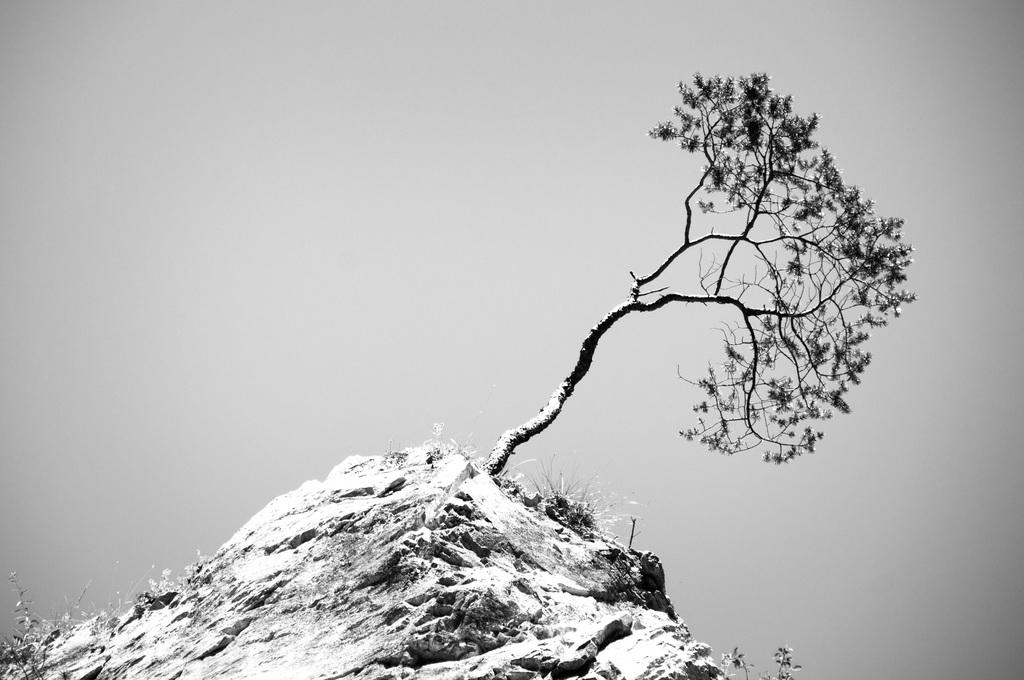What natural feature is located on the mountain in the image? There is a tree on a mountain in the image. What type of vegetation can be seen at the bottom left corner of the image? There is grass at the bottom left corner of the image. What can be seen in the background of the image? The sky is visible in the background of the image, and clouds are present. What type of jewel can be seen on the tree in the image? There are no jewels present on the tree in the image; it is a natural feature. How many legs are visible in the image? There are no legs visible in the image, as it features a tree on a mountain, grass, and a sky with clouds. 